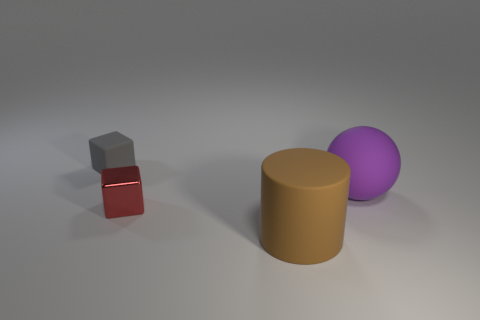Are there any other things that have the same shape as the big brown rubber thing?
Ensure brevity in your answer.  No. How many shiny objects are either small balls or purple things?
Offer a terse response. 0. There is a purple thing to the right of the tiny cube that is behind the big purple matte sphere; what is its shape?
Provide a short and direct response. Sphere. Is the material of the tiny object that is in front of the rubber sphere the same as the small thing behind the red block?
Give a very brief answer. No. How many gray blocks are behind the thing that is on the right side of the large brown matte object?
Offer a very short reply. 1. There is a matte thing that is left of the large rubber cylinder; does it have the same shape as the rubber object to the right of the big cylinder?
Give a very brief answer. No. What size is the matte thing that is behind the big rubber cylinder and to the left of the purple thing?
Your answer should be compact. Small. What is the color of the other object that is the same shape as the gray matte thing?
Ensure brevity in your answer.  Red. There is a rubber thing that is in front of the rubber object on the right side of the matte cylinder; what color is it?
Your answer should be very brief. Brown. What shape is the brown thing?
Your answer should be very brief. Cylinder. 